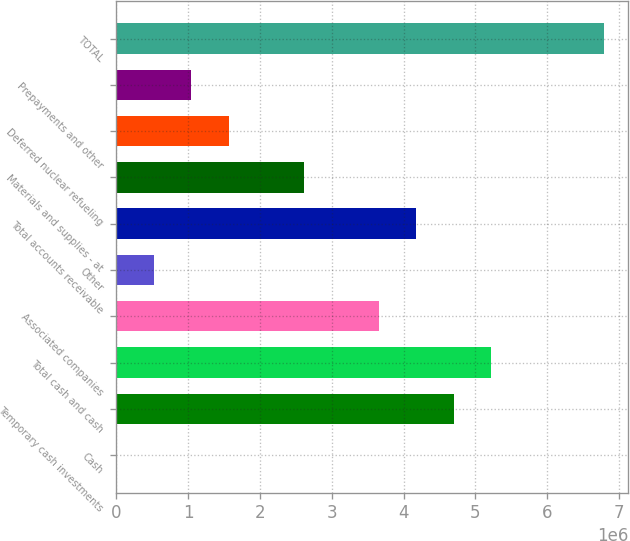Convert chart. <chart><loc_0><loc_0><loc_500><loc_500><bar_chart><fcel>Cash<fcel>Temporary cash investments<fcel>Total cash and cash<fcel>Associated companies<fcel>Other<fcel>Total accounts receivable<fcel>Materials and supplies - at<fcel>Deferred nuclear refueling<fcel>Prepayments and other<fcel>TOTAL<nl><fcel>786<fcel>4.69833e+06<fcel>5.22028e+06<fcel>3.65443e+06<fcel>522735<fcel>4.17638e+06<fcel>2.61053e+06<fcel>1.56663e+06<fcel>1.04468e+06<fcel>6.78612e+06<nl></chart> 